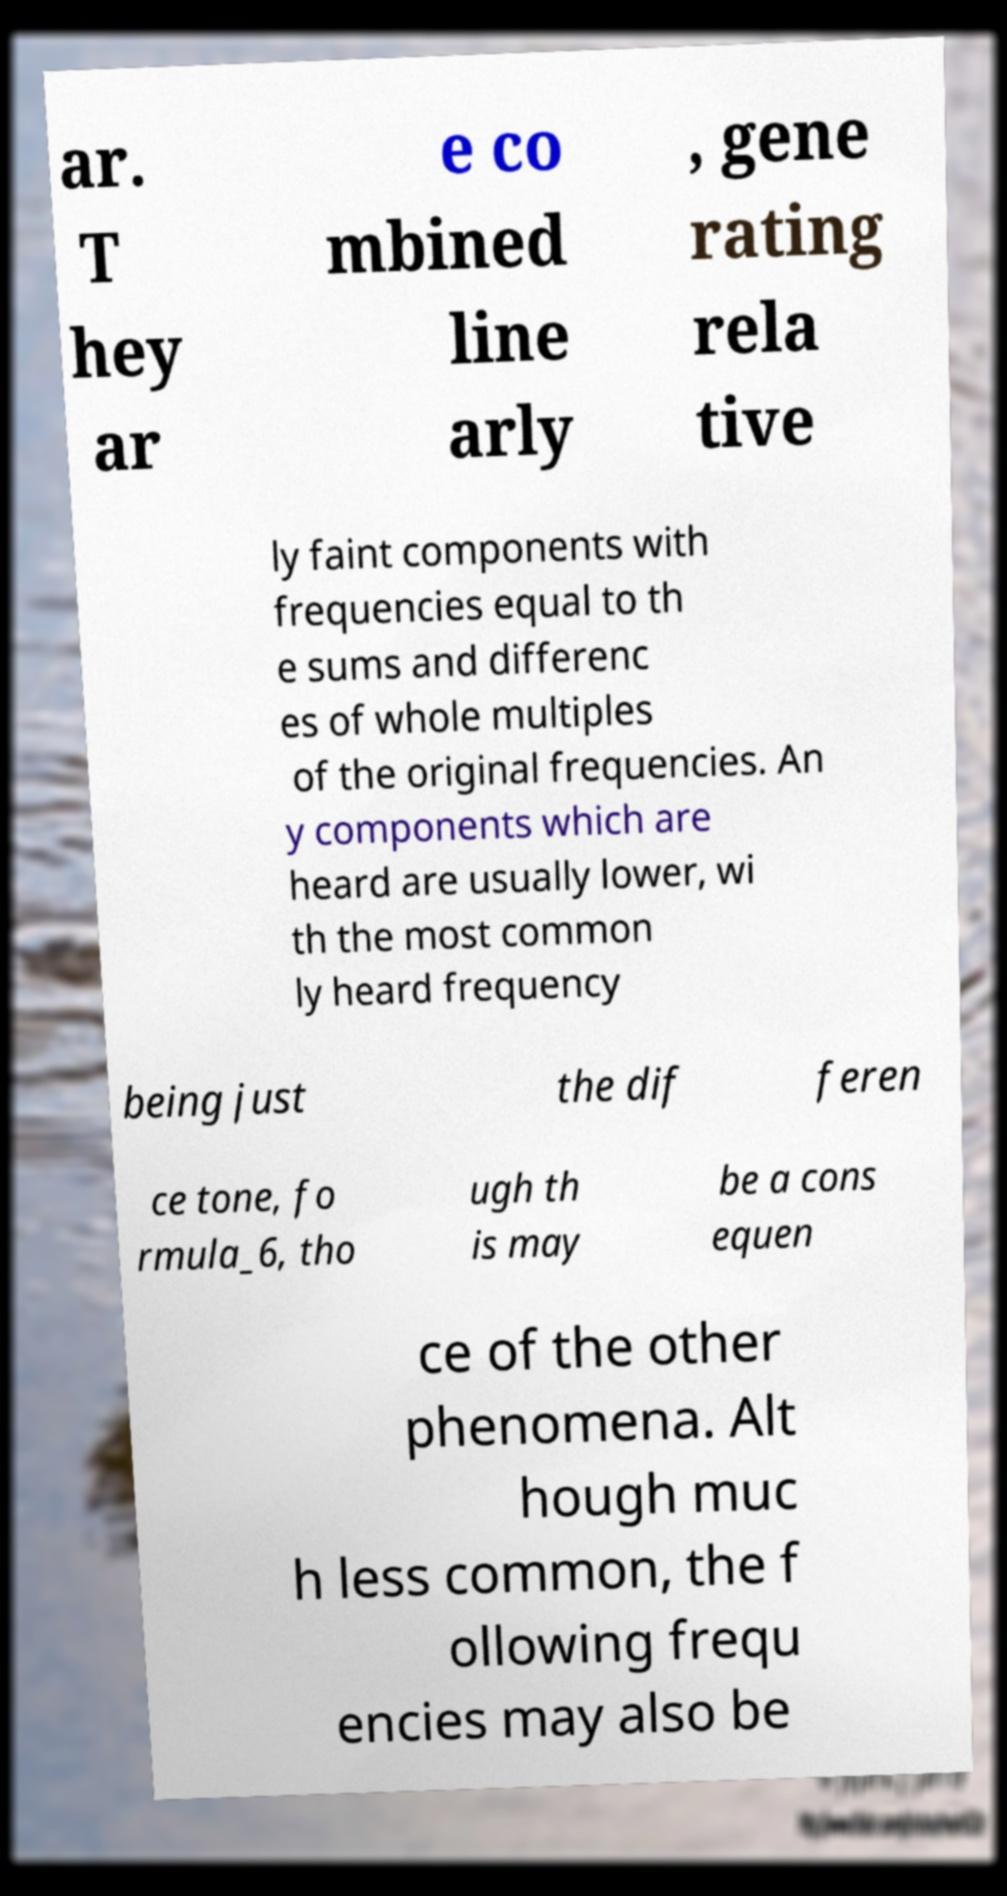I need the written content from this picture converted into text. Can you do that? ar. T hey ar e co mbined line arly , gene rating rela tive ly faint components with frequencies equal to th e sums and differenc es of whole multiples of the original frequencies. An y components which are heard are usually lower, wi th the most common ly heard frequency being just the dif feren ce tone, fo rmula_6, tho ugh th is may be a cons equen ce of the other phenomena. Alt hough muc h less common, the f ollowing frequ encies may also be 